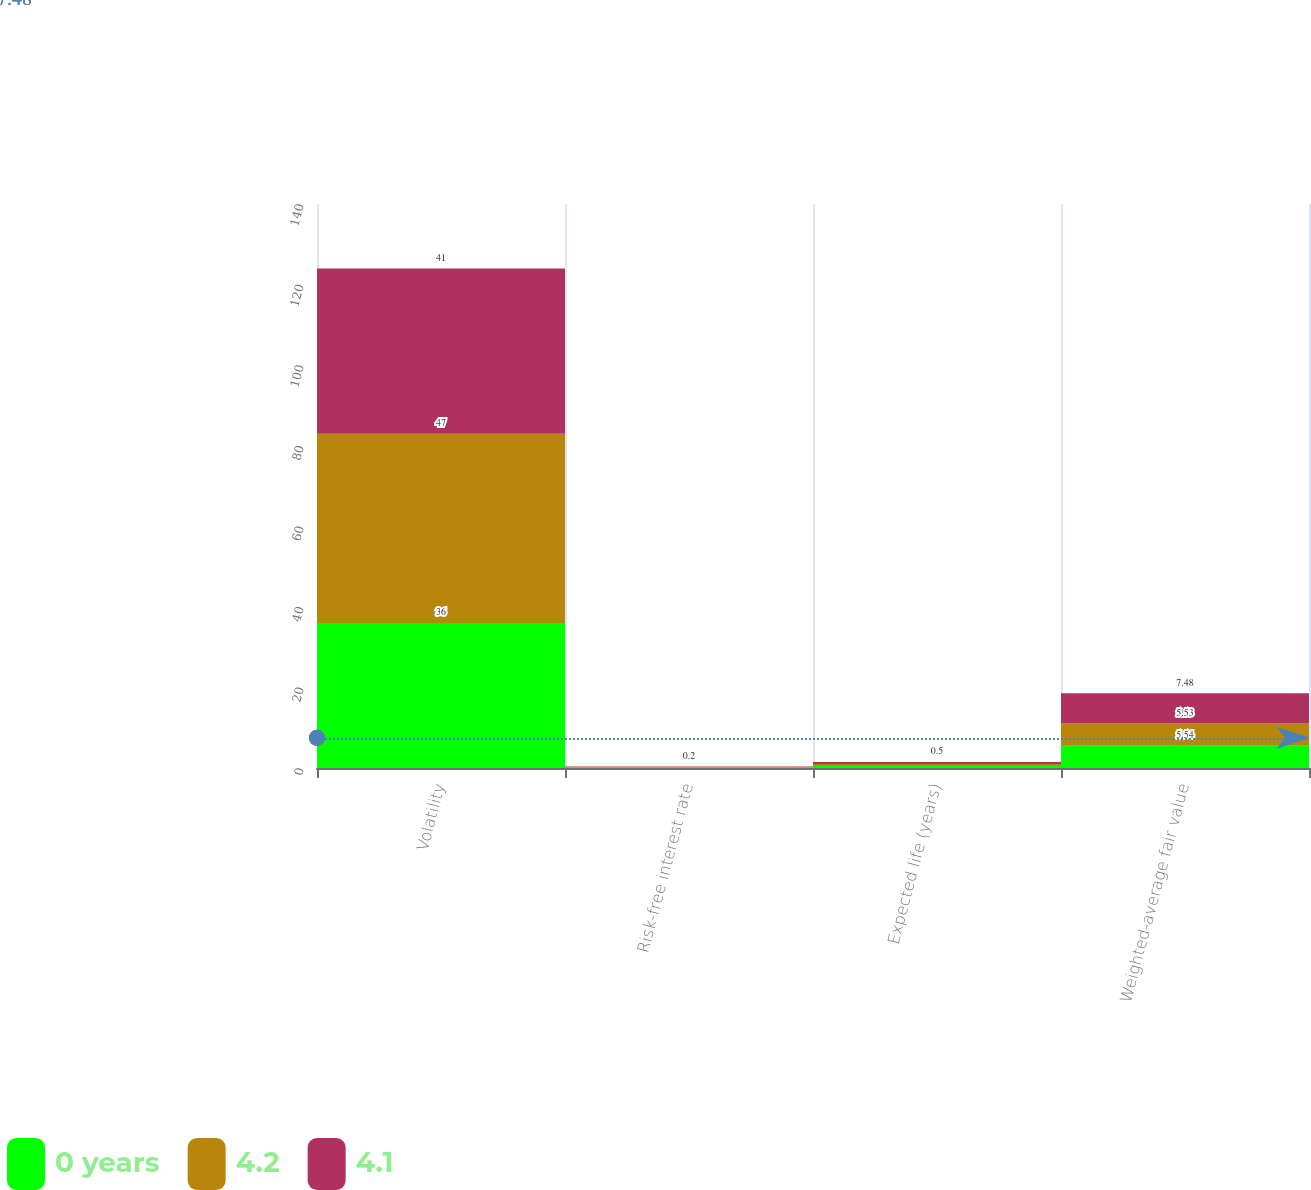<chart> <loc_0><loc_0><loc_500><loc_500><stacked_bar_chart><ecel><fcel>Volatility<fcel>Risk-free interest rate<fcel>Expected life (years)<fcel>Weighted-average fair value<nl><fcel>0 years<fcel>36<fcel>0.1<fcel>0.5<fcel>5.54<nl><fcel>4.2<fcel>47<fcel>0.1<fcel>0.5<fcel>5.53<nl><fcel>4.1<fcel>41<fcel>0.2<fcel>0.5<fcel>7.48<nl></chart> 